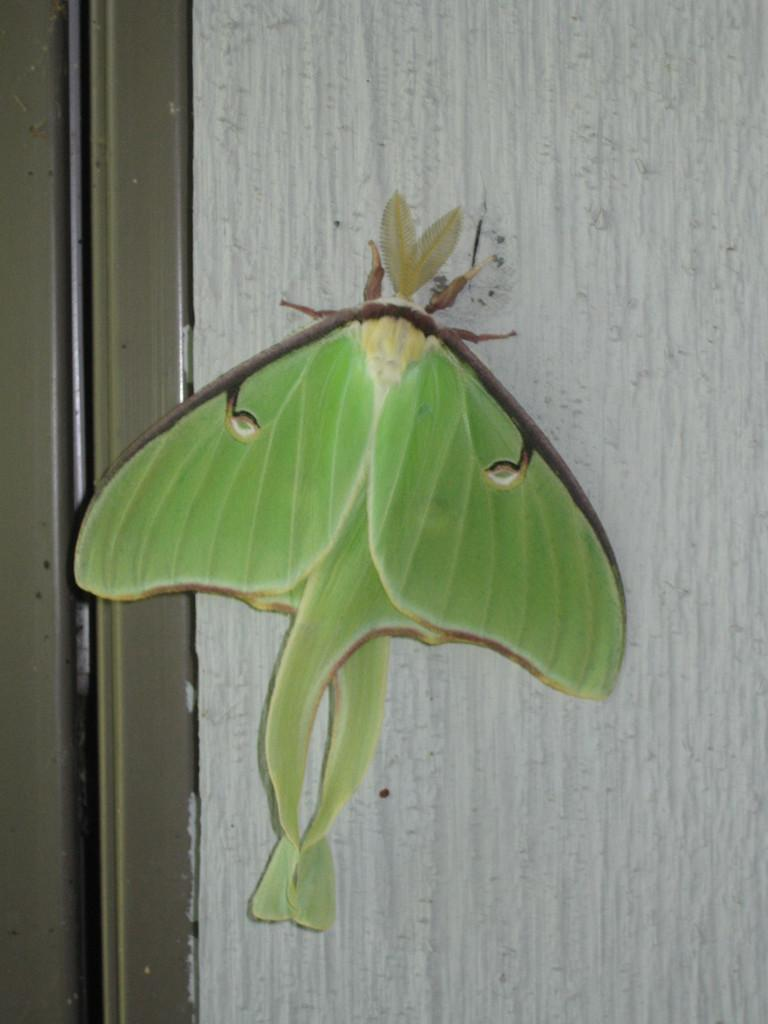What type of creature can be seen in the image? There is an insect in the image. Where is the insect located? The insect is on the wall. What type of force is being applied to the insect in the image? There is no indication of any force being applied to the insect in the image. 